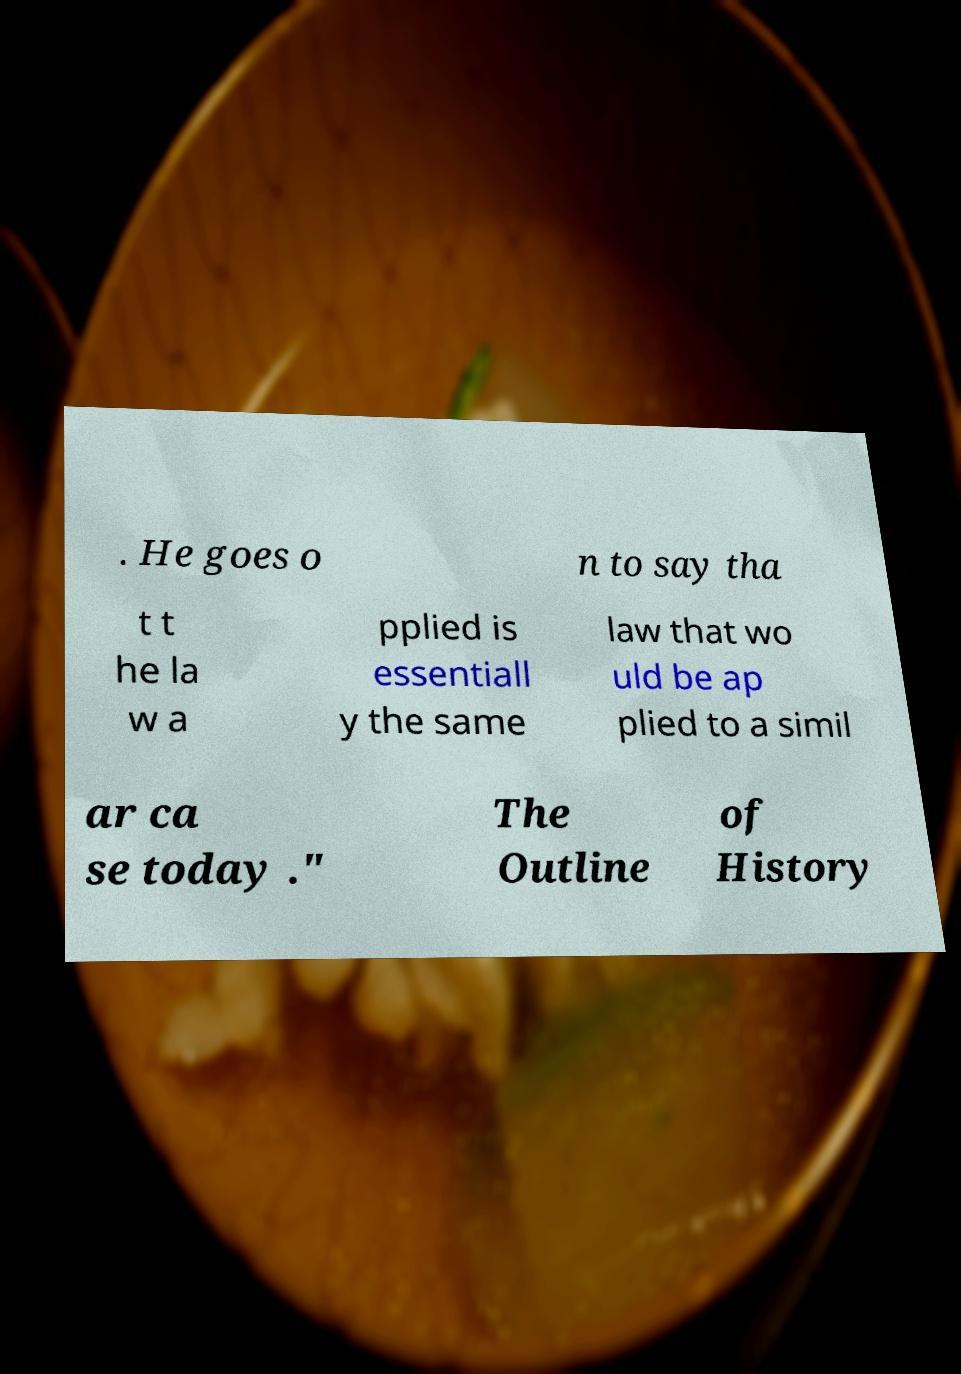Could you assist in decoding the text presented in this image and type it out clearly? . He goes o n to say tha t t he la w a pplied is essentiall y the same law that wo uld be ap plied to a simil ar ca se today ." The Outline of History 